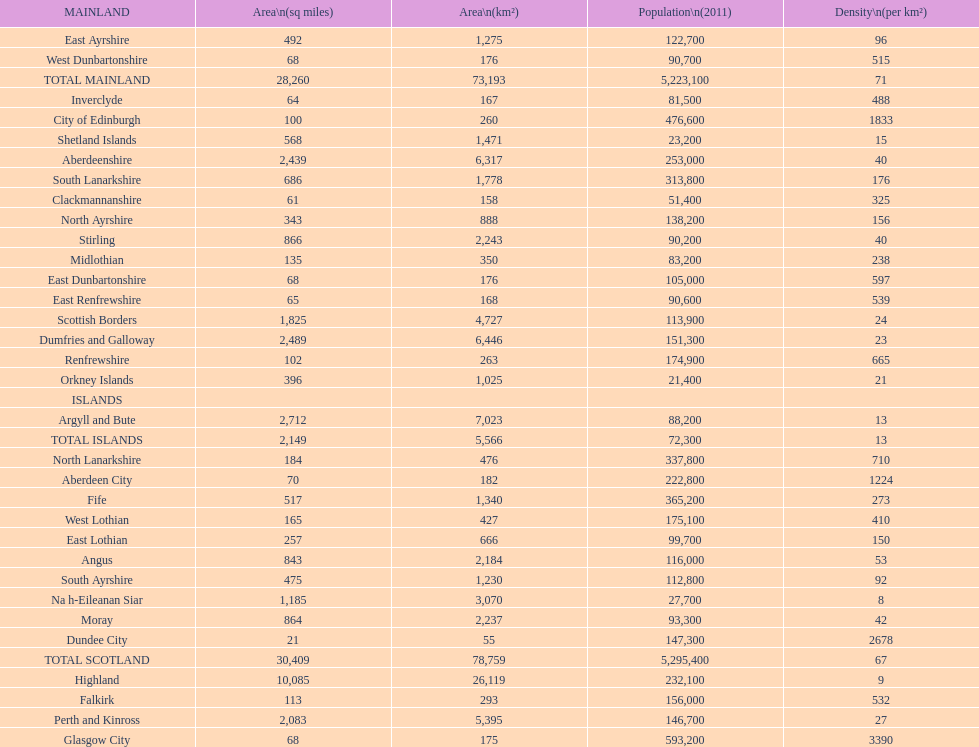In mainland urban areas, what is the usual population density? 71. 